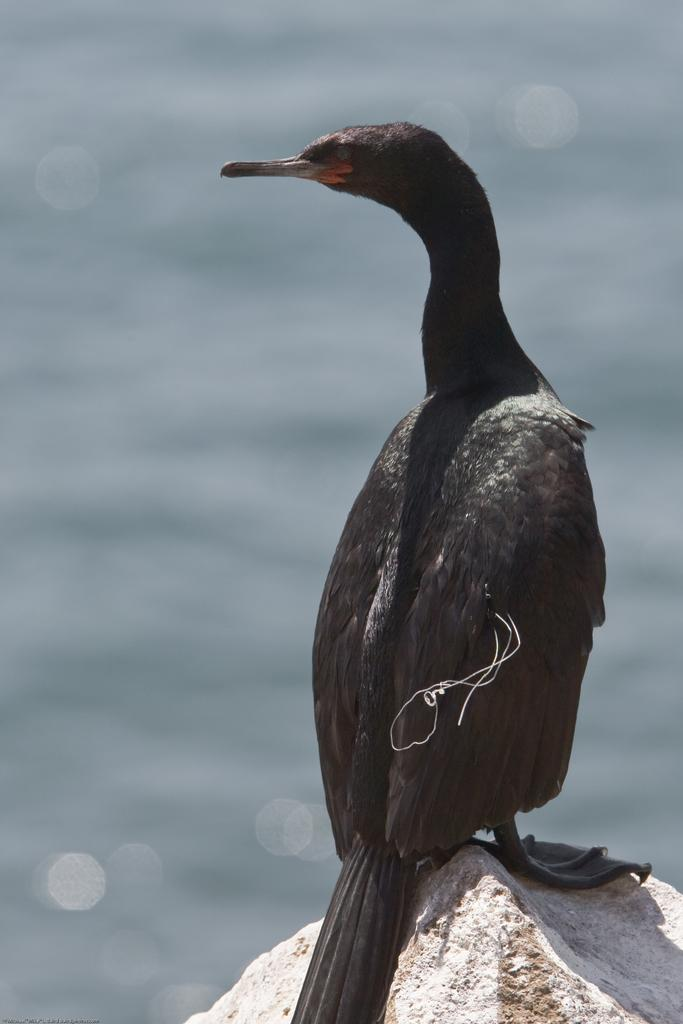What type of animal is in the image? There is a bird in the image. Where is the bird located? The bird is on a rock. Can you describe the background of the image? The background of the image is blurred. How many cakes are being held by the bird in the image? There are no cakes present in the image; it features a bird on a rock with a blurred background. 